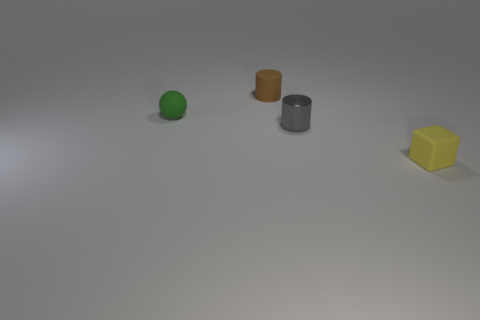Subtract all brown cylinders. How many cylinders are left? 1 Add 1 green rubber things. How many objects exist? 5 Subtract all yellow cylinders. Subtract all purple blocks. How many cylinders are left? 2 Subtract all purple spheres. How many brown cylinders are left? 1 Add 1 brown cylinders. How many brown cylinders are left? 2 Add 1 large yellow cubes. How many large yellow cubes exist? 1 Subtract 0 brown blocks. How many objects are left? 4 Subtract all cubes. How many objects are left? 3 Subtract 1 spheres. How many spheres are left? 0 Subtract all brown cylinders. Subtract all matte objects. How many objects are left? 0 